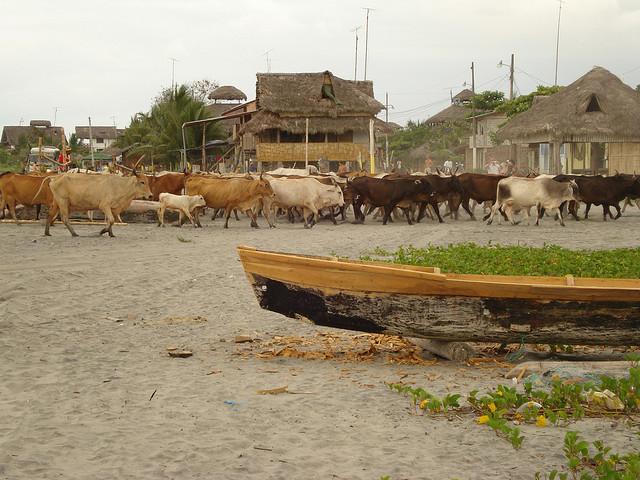Is this place near an ocean?
Short answer required. No. What is on the right foreground of the image?
Give a very brief answer. Boat. Is this in an underdeveloped village or very rich?
Give a very brief answer. Underdeveloped. 